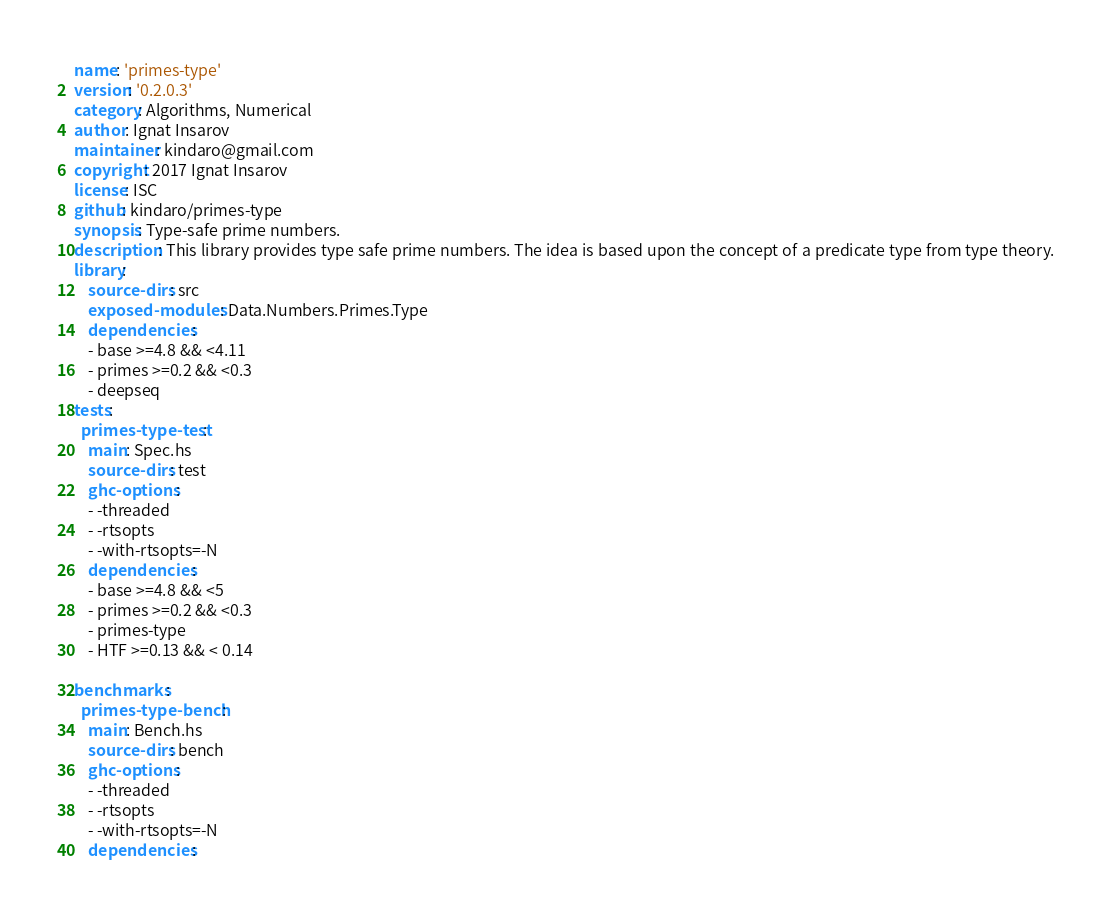<code> <loc_0><loc_0><loc_500><loc_500><_YAML_>name: 'primes-type'
version: '0.2.0.3'
category: Algorithms, Numerical
author: Ignat Insarov
maintainer: kindaro@gmail.com
copyright: 2017 Ignat Insarov
license: ISC
github: kindaro/primes-type
synopsis: Type-safe prime numbers.
description: This library provides type safe prime numbers. The idea is based upon the concept of a predicate type from type theory.
library:
    source-dirs: src
    exposed-modules: Data.Numbers.Primes.Type
    dependencies:
    - base >=4.8 && <4.11
    - primes >=0.2 && <0.3
    - deepseq
tests:
  primes-type-test:
    main: Spec.hs
    source-dirs: test
    ghc-options:
    - -threaded
    - -rtsopts
    - -with-rtsopts=-N
    dependencies:
    - base >=4.8 && <5
    - primes >=0.2 && <0.3
    - primes-type
    - HTF >=0.13 && < 0.14

benchmarks:
  primes-type-bench:
    main: Bench.hs
    source-dirs: bench
    ghc-options:
    - -threaded
    - -rtsopts
    - -with-rtsopts=-N
    dependencies:</code> 